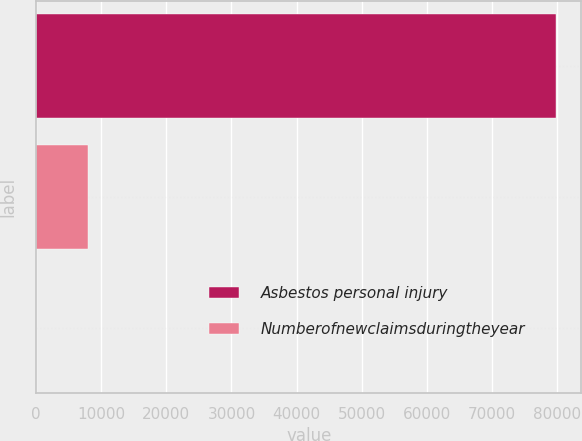Convert chart to OTSL. <chart><loc_0><loc_0><loc_500><loc_500><bar_chart><fcel>Asbestos personal injury<fcel>Numberofnewclaimsduringtheyear<fcel>Unnamed: 2<nl><fcel>79717<fcel>7997.08<fcel>28.2<nl></chart> 